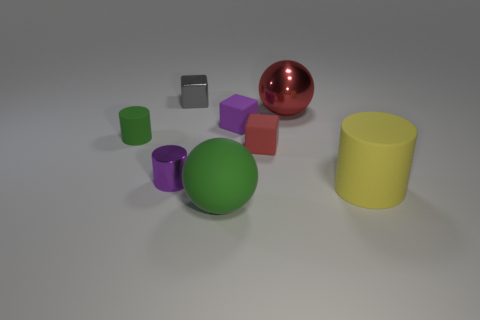Is the number of red things that are to the right of the red matte block less than the number of big rubber objects?
Your answer should be very brief. Yes. How many large things are yellow rubber things or balls?
Your answer should be compact. 3. The purple cylinder has what size?
Your answer should be very brief. Small. How many green objects are on the left side of the big green thing?
Your answer should be compact. 1. There is a red rubber thing that is the same shape as the small gray shiny object; what size is it?
Your answer should be very brief. Small. How big is the metallic object that is both in front of the tiny shiny cube and behind the small purple shiny object?
Your answer should be compact. Large. There is a large metallic thing; is it the same color as the small matte thing that is to the right of the purple rubber cube?
Your answer should be compact. Yes. How many green things are either small cylinders or metal objects?
Offer a very short reply. 1. What is the shape of the large green rubber object?
Provide a succinct answer. Sphere. How many other objects are the same shape as the big yellow matte object?
Your answer should be very brief. 2. 